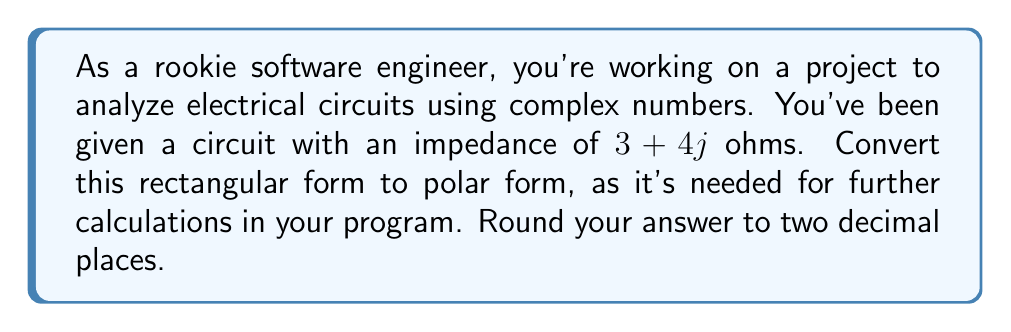Solve this math problem. To convert a complex number from rectangular form $(a + bj)$ to polar form $(r \angle \theta)$, we use the following steps:

1. Calculate the magnitude (r):
   $$r = \sqrt{a^2 + b^2}$$

2. Calculate the angle (θ) in radians:
   $$\theta = \tan^{-1}\left(\frac{b}{a}\right)$$

3. Convert the angle to degrees:
   $$\theta_{degrees} = \theta_{radians} \times \frac{180^{\circ}}{\pi}$$

For the given impedance $3 + 4j$:

1. Magnitude:
   $$r = \sqrt{3^2 + 4^2} = \sqrt{9 + 16} = \sqrt{25} = 5$$

2. Angle in radians:
   $$\theta = \tan^{-1}\left(\frac{4}{3}\right) \approx 0.9273 \text{ radians}$$

3. Angle in degrees:
   $$\theta_{degrees} = 0.9273 \times \frac{180^{\circ}}{\pi} \approx 53.13^{\circ}$$

Therefore, the polar form is $5 \angle 53.13^{\circ}$ ohms.
Answer: $5 \angle 53.13^{\circ}$ ohms 